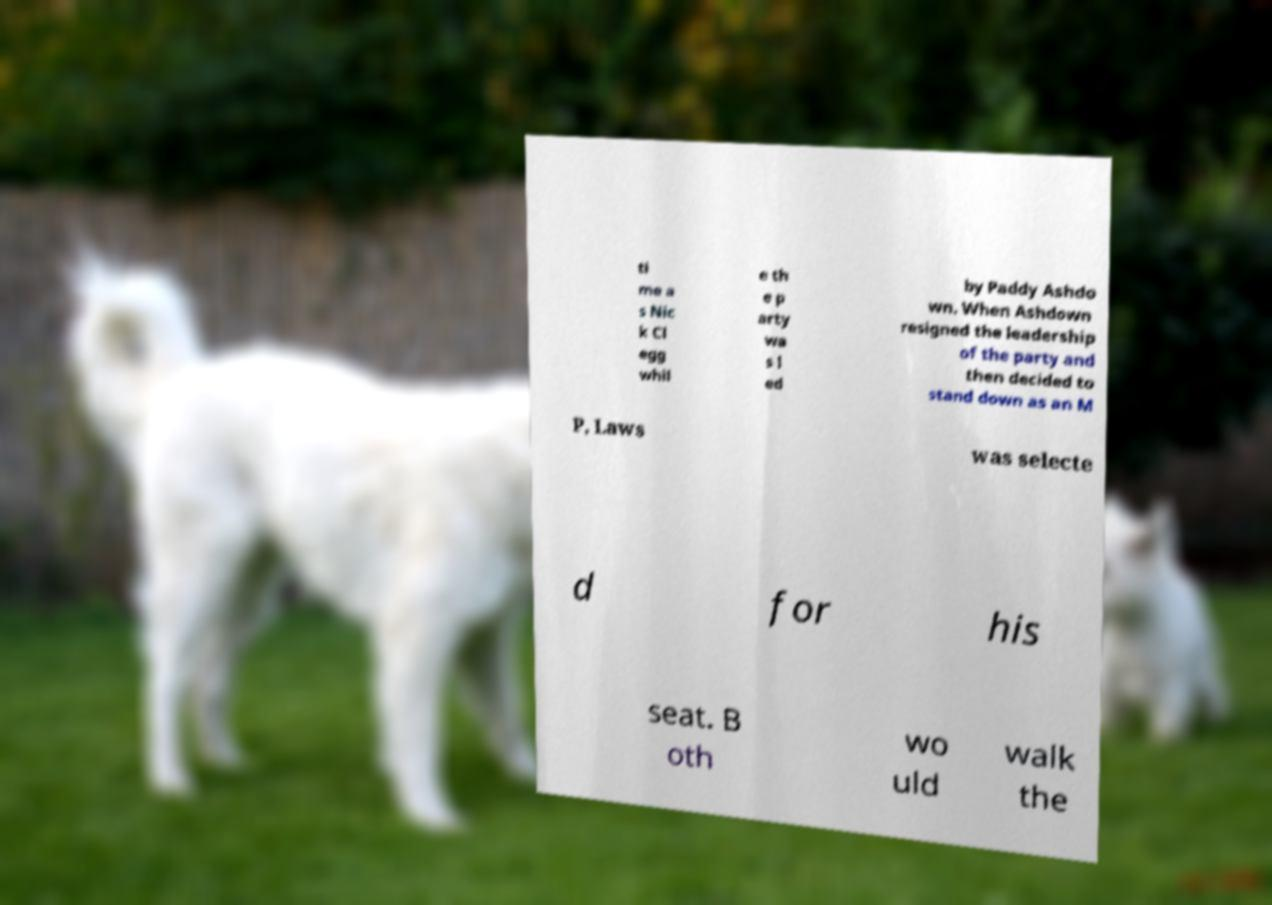Can you accurately transcribe the text from the provided image for me? ti me a s Nic k Cl egg whil e th e p arty wa s l ed by Paddy Ashdo wn. When Ashdown resigned the leadership of the party and then decided to stand down as an M P, Laws was selecte d for his seat. B oth wo uld walk the 